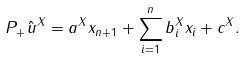<formula> <loc_0><loc_0><loc_500><loc_500>P _ { + } \hat { u } ^ { X } = a ^ { X } x _ { n + 1 } + \sum _ { i = 1 } ^ { n } b _ { i } ^ { X } x _ { i } + c ^ { X } .</formula> 